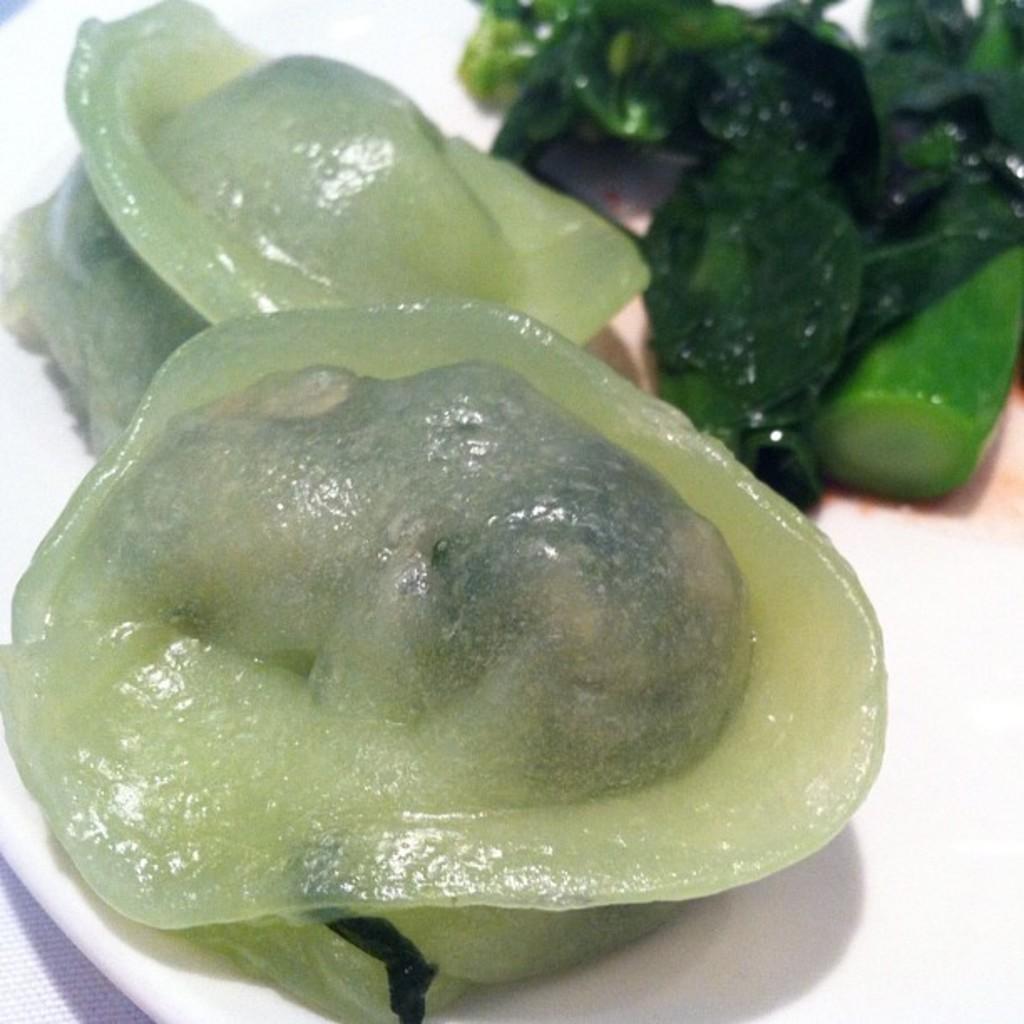Describe this image in one or two sentences. In this image I can see sea food and vegetables in a plate may be kept on the table. This image is taken may be in a room. 